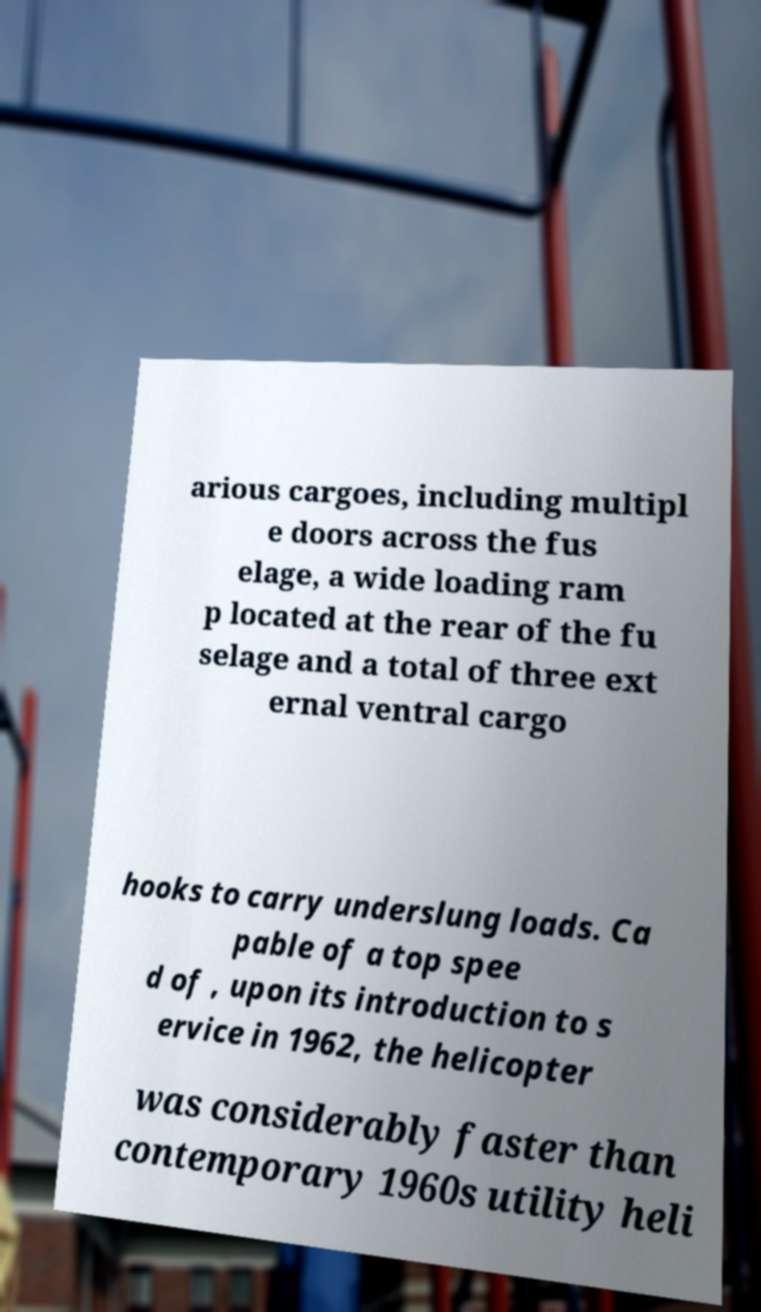Can you read and provide the text displayed in the image?This photo seems to have some interesting text. Can you extract and type it out for me? arious cargoes, including multipl e doors across the fus elage, a wide loading ram p located at the rear of the fu selage and a total of three ext ernal ventral cargo hooks to carry underslung loads. Ca pable of a top spee d of , upon its introduction to s ervice in 1962, the helicopter was considerably faster than contemporary 1960s utility heli 